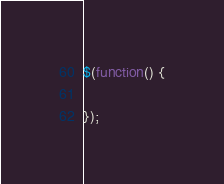<code> <loc_0><loc_0><loc_500><loc_500><_JavaScript_>$(function() {
	
});

</code> 